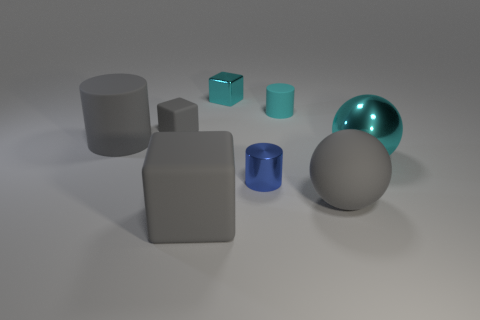Subtract all gray cubes. How many cubes are left? 1 Subtract 1 blocks. How many blocks are left? 2 Add 2 blue rubber cylinders. How many objects exist? 10 Add 5 big metallic balls. How many big metallic balls are left? 6 Add 5 spheres. How many spheres exist? 7 Subtract 0 purple cylinders. How many objects are left? 8 Subtract all cylinders. How many objects are left? 5 Subtract all small cyan metallic cubes. Subtract all gray things. How many objects are left? 3 